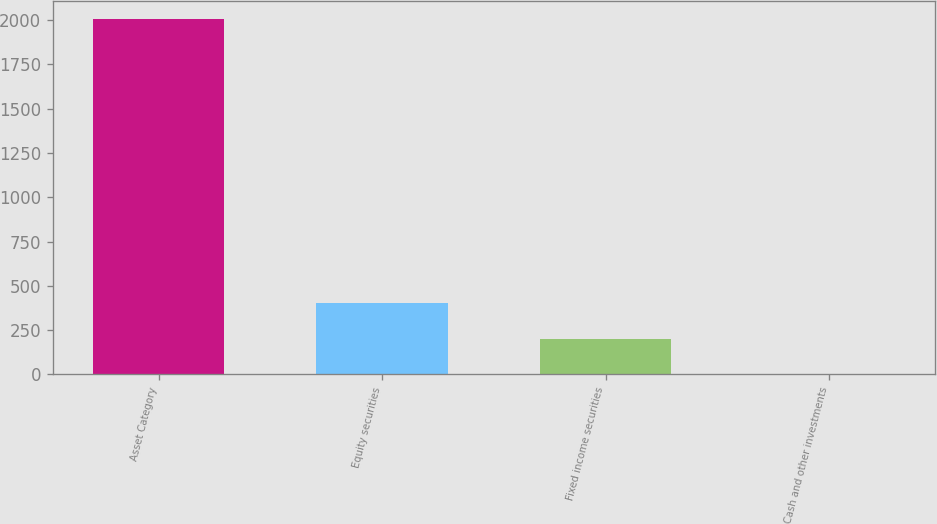Convert chart to OTSL. <chart><loc_0><loc_0><loc_500><loc_500><bar_chart><fcel>Asset Category<fcel>Equity securities<fcel>Fixed income securities<fcel>Cash and other investments<nl><fcel>2005<fcel>402.6<fcel>202.3<fcel>2<nl></chart> 